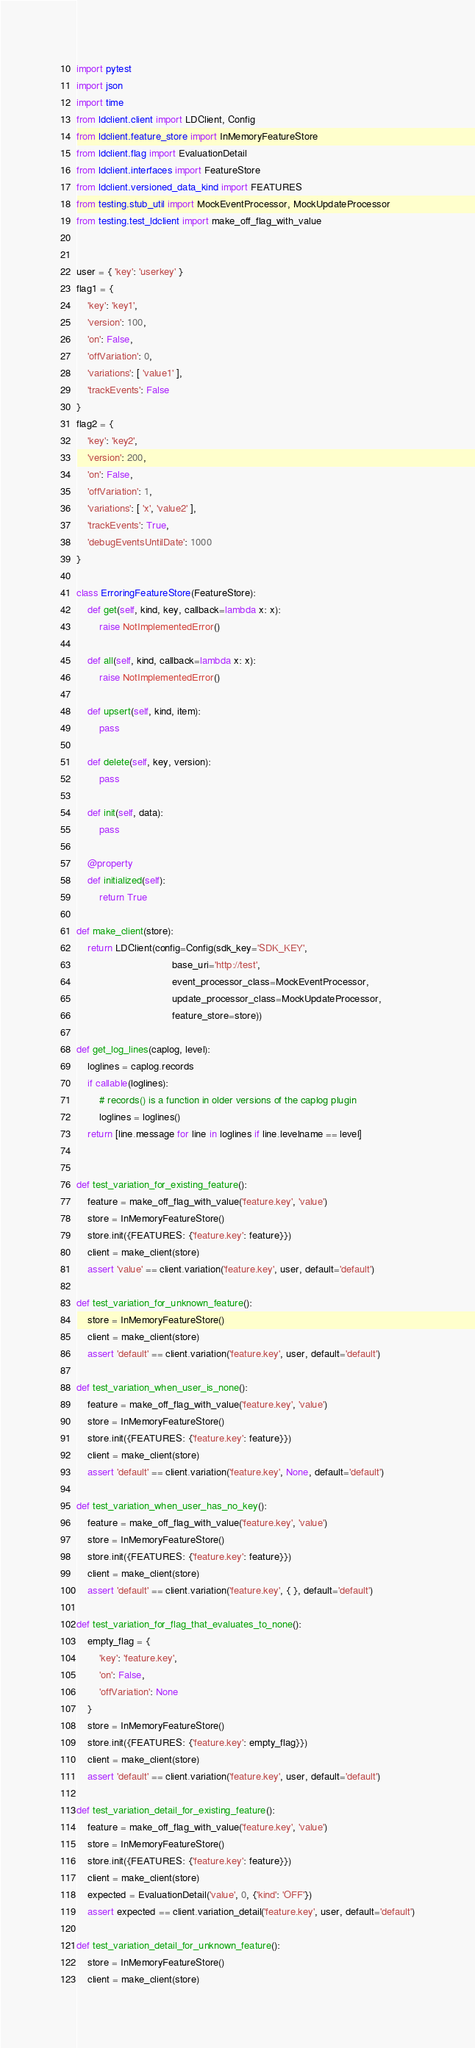<code> <loc_0><loc_0><loc_500><loc_500><_Python_>import pytest
import json
import time
from ldclient.client import LDClient, Config
from ldclient.feature_store import InMemoryFeatureStore
from ldclient.flag import EvaluationDetail
from ldclient.interfaces import FeatureStore
from ldclient.versioned_data_kind import FEATURES
from testing.stub_util import MockEventProcessor, MockUpdateProcessor
from testing.test_ldclient import make_off_flag_with_value


user = { 'key': 'userkey' }
flag1 = {
    'key': 'key1',
    'version': 100,
    'on': False,
    'offVariation': 0,
    'variations': [ 'value1' ],
    'trackEvents': False
}
flag2 = {
    'key': 'key2',
    'version': 200,
    'on': False,
    'offVariation': 1,
    'variations': [ 'x', 'value2' ],
    'trackEvents': True,
    'debugEventsUntilDate': 1000
}

class ErroringFeatureStore(FeatureStore):
    def get(self, kind, key, callback=lambda x: x):
        raise NotImplementedError()
    
    def all(self, kind, callback=lambda x: x):
        raise NotImplementedError()
    
    def upsert(self, kind, item):
        pass
    
    def delete(self, key, version):
        pass
    
    def init(self, data):
        pass
    
    @property
    def initialized(self):
        return True

def make_client(store):
    return LDClient(config=Config(sdk_key='SDK_KEY',
                                  base_uri='http://test',
                                  event_processor_class=MockEventProcessor,
                                  update_processor_class=MockUpdateProcessor,
                                  feature_store=store))

def get_log_lines(caplog, level):
    loglines = caplog.records
    if callable(loglines):
        # records() is a function in older versions of the caplog plugin
        loglines = loglines()
    return [line.message for line in loglines if line.levelname == level]


def test_variation_for_existing_feature():
    feature = make_off_flag_with_value('feature.key', 'value')
    store = InMemoryFeatureStore()
    store.init({FEATURES: {'feature.key': feature}})
    client = make_client(store)
    assert 'value' == client.variation('feature.key', user, default='default')

def test_variation_for_unknown_feature():
    store = InMemoryFeatureStore()
    client = make_client(store)
    assert 'default' == client.variation('feature.key', user, default='default')

def test_variation_when_user_is_none():
    feature = make_off_flag_with_value('feature.key', 'value')
    store = InMemoryFeatureStore()
    store.init({FEATURES: {'feature.key': feature}})
    client = make_client(store)
    assert 'default' == client.variation('feature.key', None, default='default')

def test_variation_when_user_has_no_key():
    feature = make_off_flag_with_value('feature.key', 'value')
    store = InMemoryFeatureStore()
    store.init({FEATURES: {'feature.key': feature}})
    client = make_client(store)
    assert 'default' == client.variation('feature.key', { }, default='default')

def test_variation_for_flag_that_evaluates_to_none():
    empty_flag = {
        'key': 'feature.key',
        'on': False,
        'offVariation': None
    }
    store = InMemoryFeatureStore()
    store.init({FEATURES: {'feature.key': empty_flag}})
    client = make_client(store)
    assert 'default' == client.variation('feature.key', user, default='default')

def test_variation_detail_for_existing_feature():
    feature = make_off_flag_with_value('feature.key', 'value')
    store = InMemoryFeatureStore()
    store.init({FEATURES: {'feature.key': feature}})
    client = make_client(store)
    expected = EvaluationDetail('value', 0, {'kind': 'OFF'})
    assert expected == client.variation_detail('feature.key', user, default='default')

def test_variation_detail_for_unknown_feature():
    store = InMemoryFeatureStore()
    client = make_client(store)</code> 